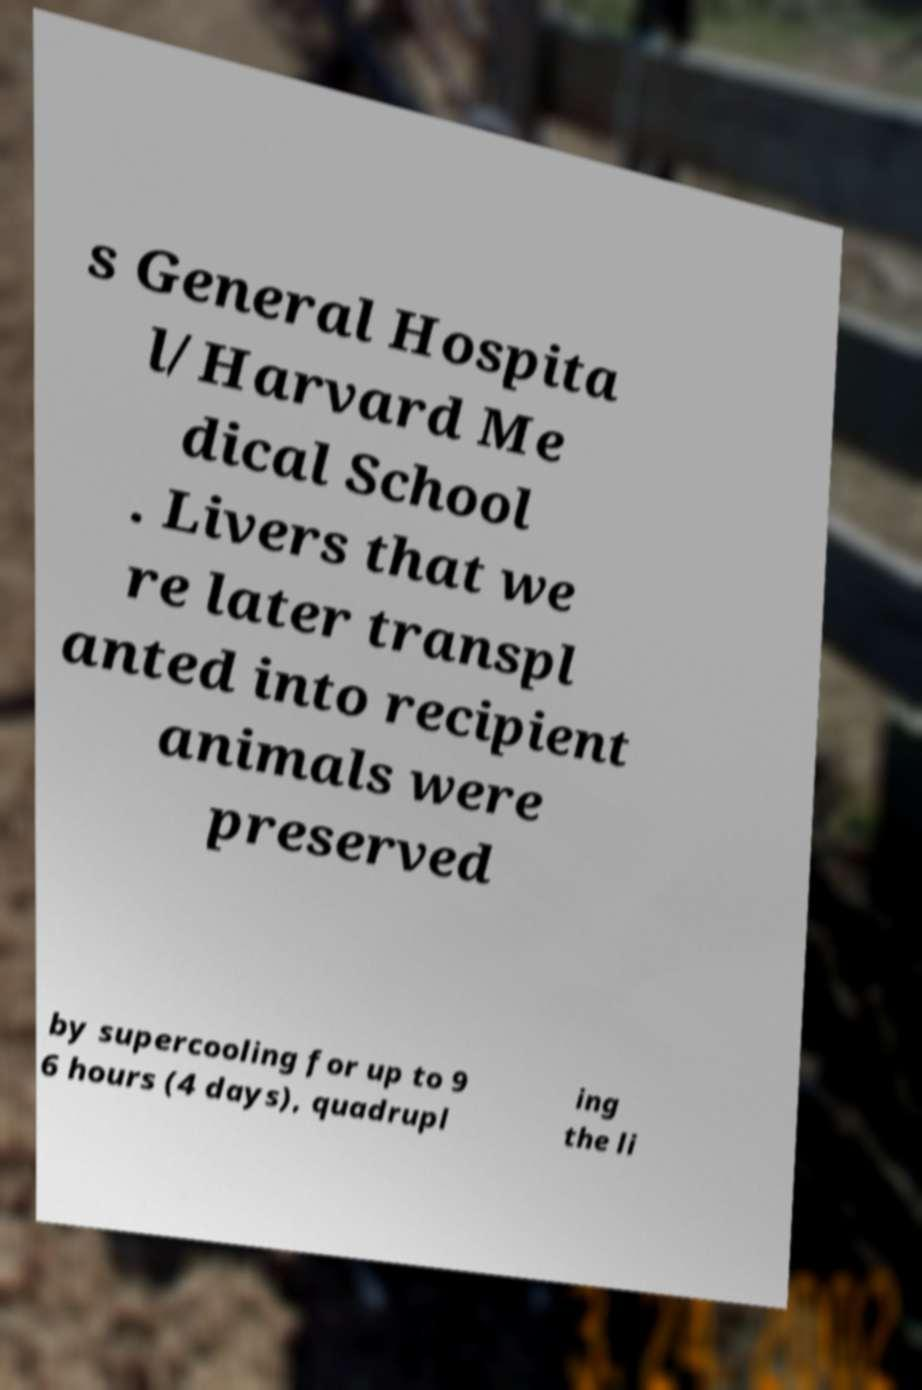Can you read and provide the text displayed in the image?This photo seems to have some interesting text. Can you extract and type it out for me? s General Hospita l/Harvard Me dical School . Livers that we re later transpl anted into recipient animals were preserved by supercooling for up to 9 6 hours (4 days), quadrupl ing the li 